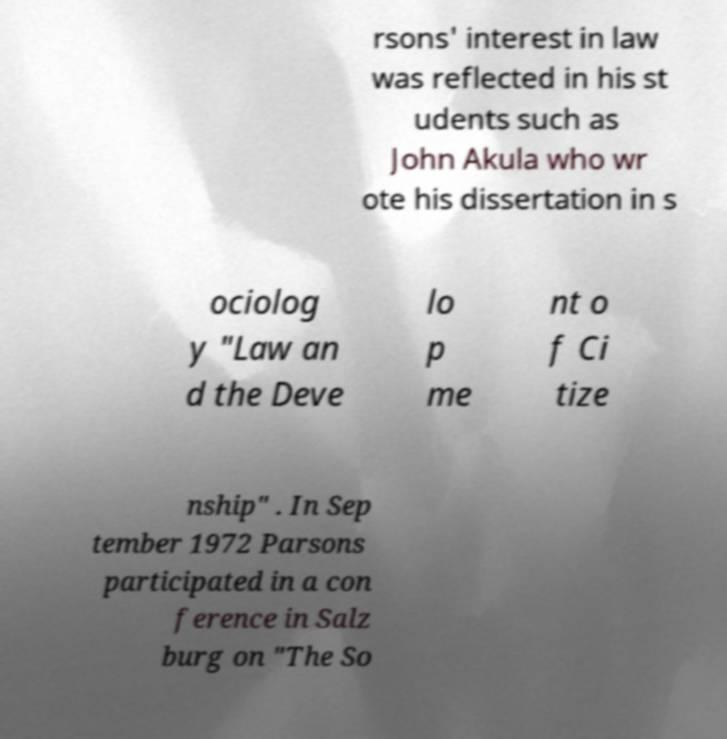I need the written content from this picture converted into text. Can you do that? rsons' interest in law was reflected in his st udents such as John Akula who wr ote his dissertation in s ociolog y "Law an d the Deve lo p me nt o f Ci tize nship" . In Sep tember 1972 Parsons participated in a con ference in Salz burg on "The So 